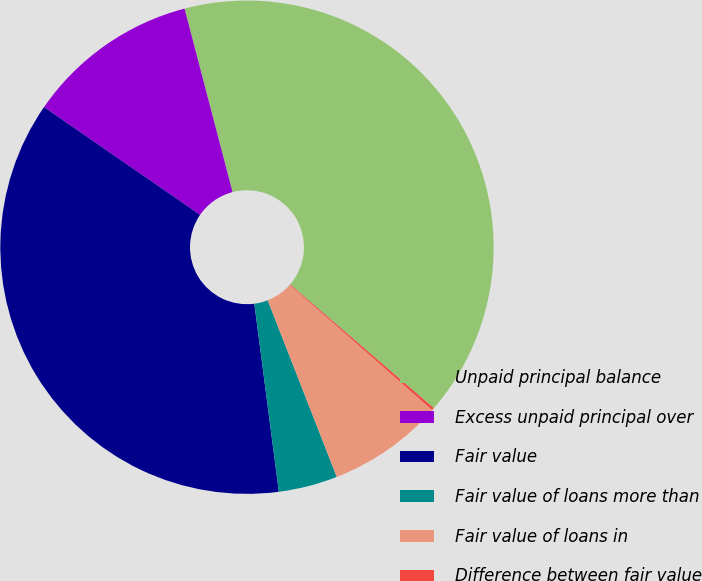Convert chart. <chart><loc_0><loc_0><loc_500><loc_500><pie_chart><fcel>Unpaid principal balance<fcel>Excess unpaid principal over<fcel>Fair value<fcel>Fair value of loans more than<fcel>Fair value of loans in<fcel>Difference between fair value<nl><fcel>40.39%<fcel>11.31%<fcel>36.68%<fcel>3.87%<fcel>7.59%<fcel>0.16%<nl></chart> 